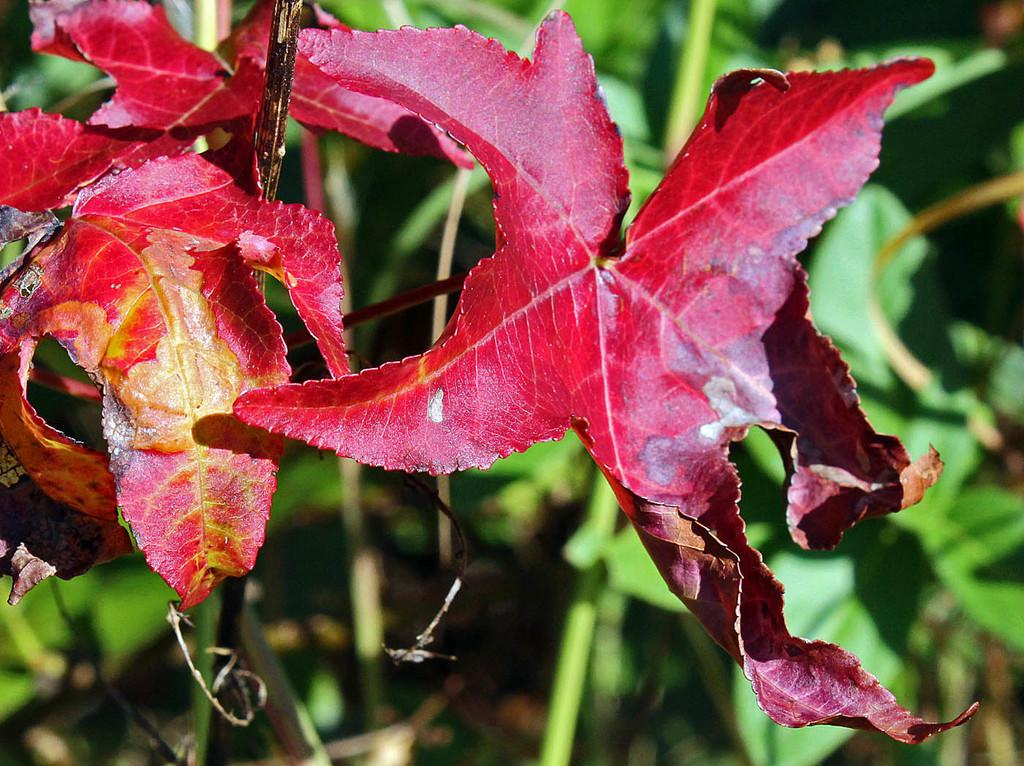What color are the leaves in the image? The leaves in the image are maroon. What can be seen in the background of the image? There are plants in the background of the image. How would you describe the background of the image? The background of the image is blurry. How many stoves are visible in the image? There are no stoves present in the image. What season is depicted in the image based on the color of the leaves? The color of the leaves does not necessarily indicate a specific season, as maroon leaves can be found in various seasons. 